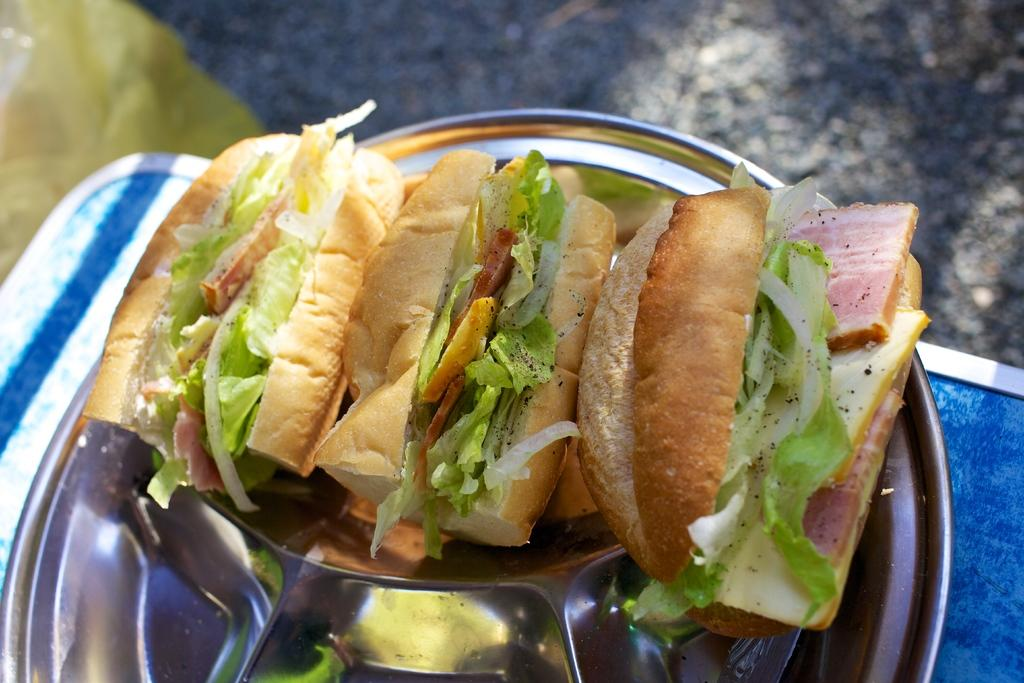What is on the plate that is visible in the image? There are food items on a plate in the image. What is the plate placed on? The plate is placed on a blue object, possibly a cloth. What can be seen at the top of the image? The ground is visible at the top of the image. What is in the top left corner of the image? There is an object in the top left corner of the image. Where is the sister sitting in the image? There is no sister present in the image. What type of sack is being used to store the food items on the plate? There is no sack visible in the image; the food items are on a plate. 